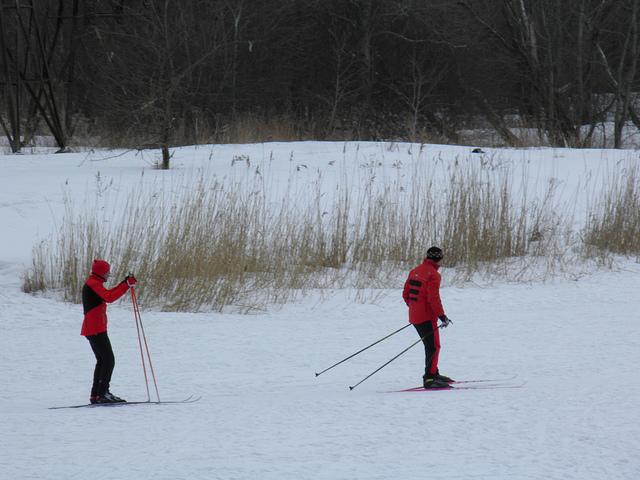How many ski poles do you see?
Keep it brief. 4. Are these the proper positions for skiing?
Give a very brief answer. Yes. Is there snow on the ground?
Write a very short answer. Yes. 